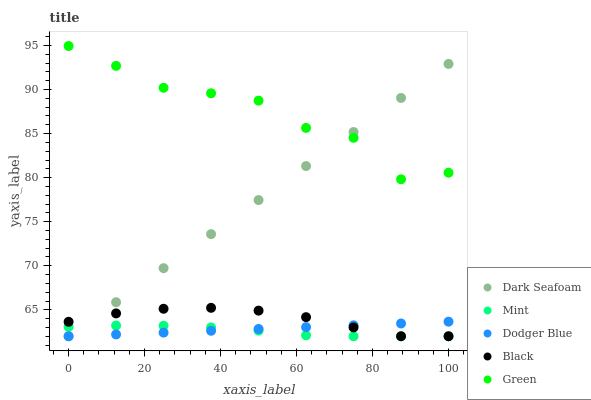Does Mint have the minimum area under the curve?
Answer yes or no. Yes. Does Green have the maximum area under the curve?
Answer yes or no. Yes. Does Dark Seafoam have the minimum area under the curve?
Answer yes or no. No. Does Dark Seafoam have the maximum area under the curve?
Answer yes or no. No. Is Dodger Blue the smoothest?
Answer yes or no. Yes. Is Green the roughest?
Answer yes or no. Yes. Is Dark Seafoam the smoothest?
Answer yes or no. No. Is Dark Seafoam the roughest?
Answer yes or no. No. Does Dodger Blue have the lowest value?
Answer yes or no. Yes. Does Green have the lowest value?
Answer yes or no. No. Does Green have the highest value?
Answer yes or no. Yes. Does Dark Seafoam have the highest value?
Answer yes or no. No. Is Mint less than Green?
Answer yes or no. Yes. Is Green greater than Black?
Answer yes or no. Yes. Does Dark Seafoam intersect Mint?
Answer yes or no. Yes. Is Dark Seafoam less than Mint?
Answer yes or no. No. Is Dark Seafoam greater than Mint?
Answer yes or no. No. Does Mint intersect Green?
Answer yes or no. No. 